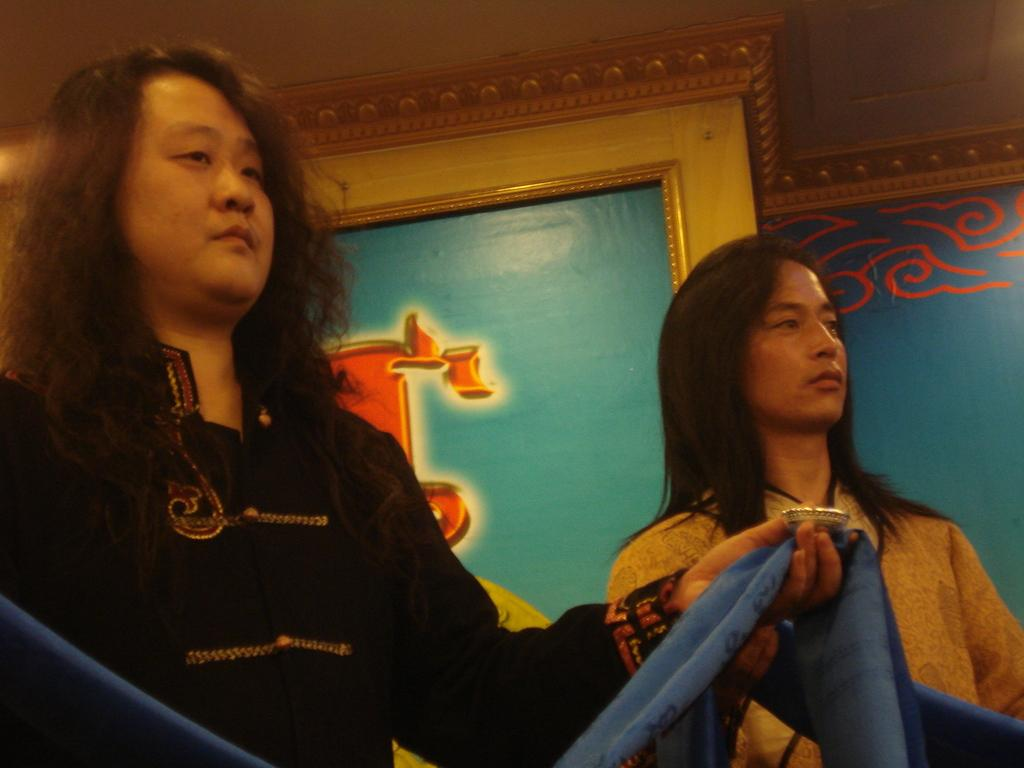What are the people in the image doing? The people in the image are standing and holding clothes. What might the people be doing with the clothes they are holding? The people might be hanging or folding the clothes. What can be seen in the background of the image? There is a frame on a wall in the background of the image. What type of hill can be seen in the image? There is no hill present in the image. Can you tell me what kind of insect is crawling on the clothes in the image? There are no insects visible in the image. 